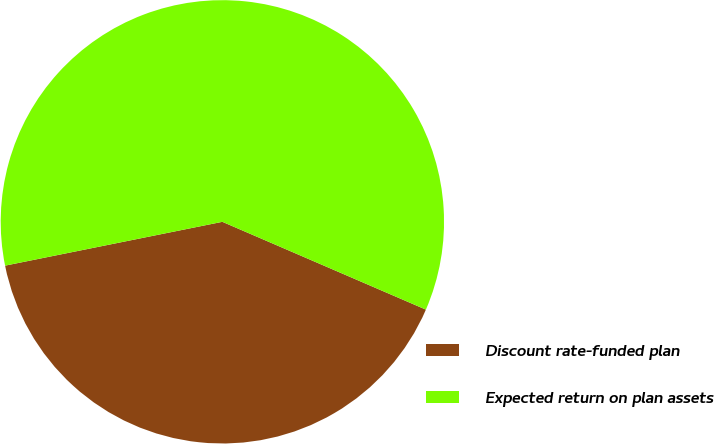Convert chart to OTSL. <chart><loc_0><loc_0><loc_500><loc_500><pie_chart><fcel>Discount rate-funded plan<fcel>Expected return on plan assets<nl><fcel>40.35%<fcel>59.65%<nl></chart> 